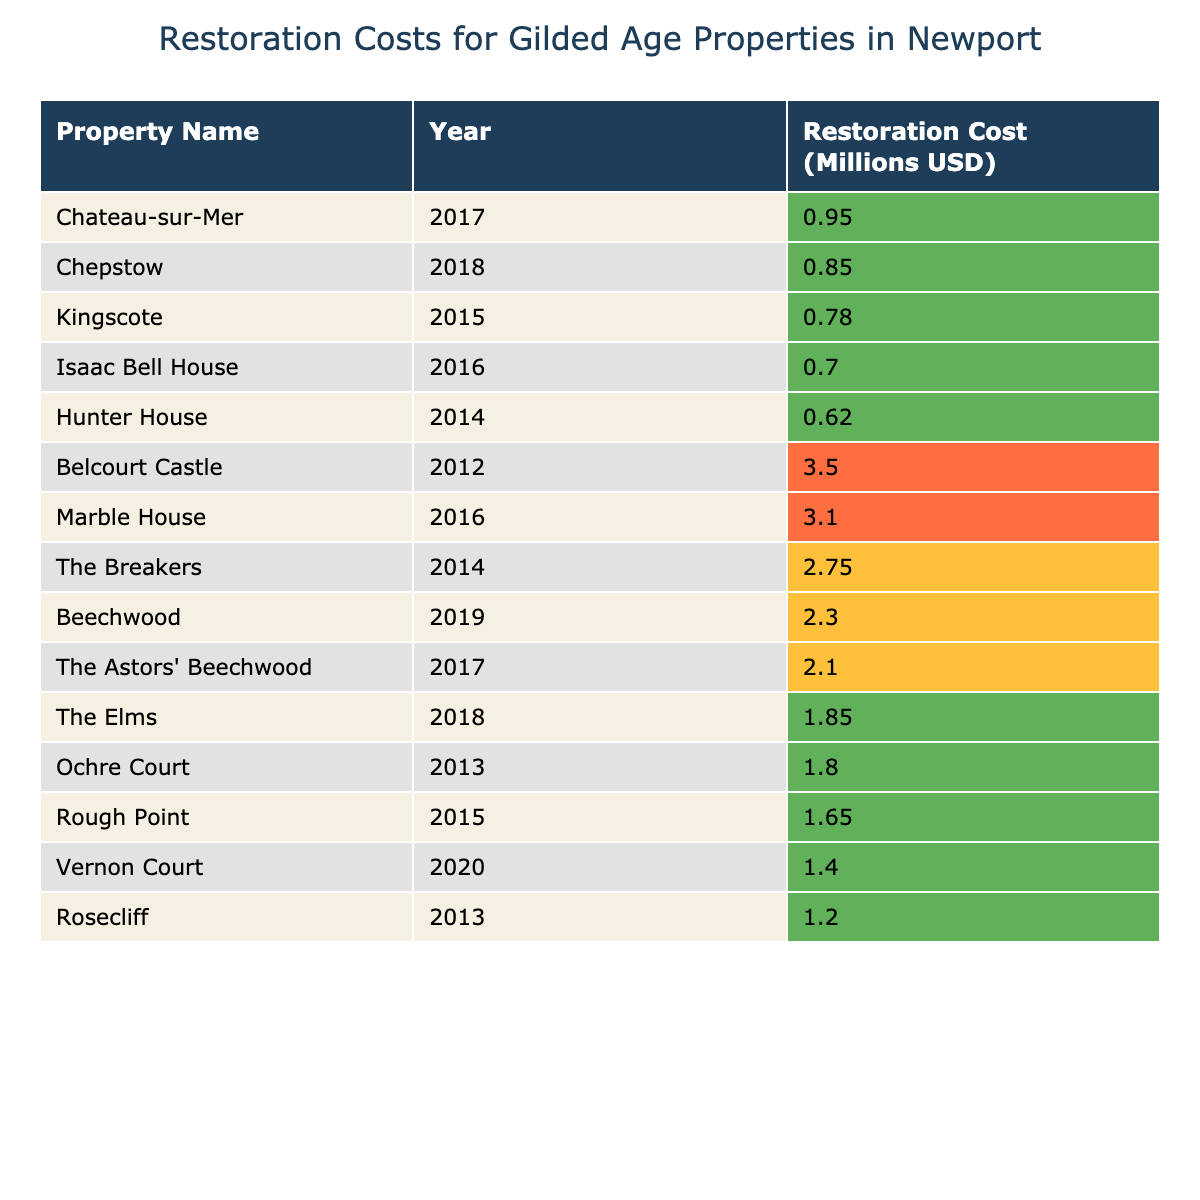What is the restoration cost of The Breakers? The table shows that The Breakers has a restoration cost of $2,750,000.
Answer: $2,750,000 In which year did Rosecliff undergo restoration? The table lists Rosecliff and indicates that it was restored in 2013.
Answer: 2013 Which property had the highest restoration cost? The table supports that Belcourt Castle had the highest restoration cost at $3,500,000.
Answer: Belcourt Castle What is the average restoration cost for the properties listed? To find the average, add all the restoration costs: (2,750,000 + 3,100,000 + 1,850,000 + 1,200,000 + 950,000 + 780,000 + 2,300,000 + 3,500,000 + 1,400,000 + 620,000 + 850,000 + 700,000 + 1,650,000 + 2,100,000 + 1,800,000) = 23,430,000. Divide by the number of properties (14) to get approximately 1,669,286.
Answer: Approximately $1,669,286 Did any property have a restoration cost under $1 million? By examining the table, it can be confirmed that no property had a restoration cost under $1 million.
Answer: No How many properties had restoration costs over $2 million? Counting the properties that have costs above $2 million in the table, we find 5 (The Breakers, Marble House, Beechwood, Belcourt Castle, and The Astors' Beechwood).
Answer: 5 What's the total restoration cost for properties restored in 2018? The properties restored in 2018 are The Elms ($1,850,000) and Chepstow ($850,000). Adding these gives $1,850,000 + $850,000 = $2,700,000.
Answer: $2,700,000 Which property was restored in 2016 and what was its cost? The table indicates that both Marble House and Isaac Bell House were restored in 2016, with restoration costs of $3,100,000 and $700,000, respectively.
Answer: Marble House, $3,100,000 Is the restoration cost of Chateau-sur-Mer greater than that of Kingscote? Looking at the table, Chateau-sur-Mer cost $950,000 while Kingscote cost $780,000, meaning Chateau-sur-Mer has a greater cost.
Answer: Yes What is the difference in restoration costs between the most expensive and least expensive properties? The most expensive property is Belcourt Castle at $3,500,000, and the least expensive is Kingscote at $780,000. The difference is $3,500,000 - $780,000 = $2,720,000.
Answer: $2,720,000 Which decade had the largest amount spent on restoration, based only on this table? Summing the restoration costs from the properties listed for each year shows consistent costs across different years; however, the highest single year cost of $3,100,000 in 2016 could indicate a peak year for restoration spending within the last decade as a whole.
Answer: 2016 (not a decade, but the largest single expenditure year in the data) 